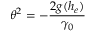<formula> <loc_0><loc_0><loc_500><loc_500>\theta ^ { 2 } = - \frac { 2 g ( h _ { e } ) } { \gamma _ { 0 } }</formula> 